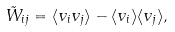<formula> <loc_0><loc_0><loc_500><loc_500>\tilde { W } _ { i j } = \langle v _ { i } v _ { j } \rangle - \langle v _ { i } \rangle \langle v _ { j } \rangle ,</formula> 